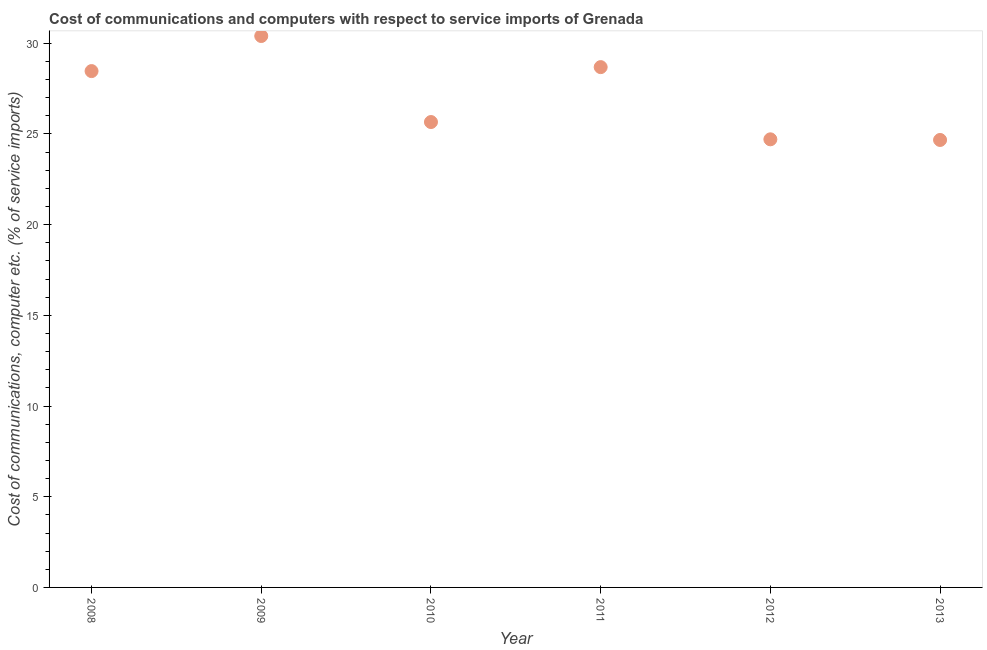What is the cost of communications and computer in 2011?
Your answer should be very brief. 28.68. Across all years, what is the maximum cost of communications and computer?
Ensure brevity in your answer.  30.4. Across all years, what is the minimum cost of communications and computer?
Give a very brief answer. 24.67. In which year was the cost of communications and computer maximum?
Your response must be concise. 2009. In which year was the cost of communications and computer minimum?
Give a very brief answer. 2013. What is the sum of the cost of communications and computer?
Your response must be concise. 162.57. What is the difference between the cost of communications and computer in 2009 and 2011?
Your response must be concise. 1.71. What is the average cost of communications and computer per year?
Give a very brief answer. 27.1. What is the median cost of communications and computer?
Provide a succinct answer. 27.06. Do a majority of the years between 2012 and 2008 (inclusive) have cost of communications and computer greater than 10 %?
Provide a short and direct response. Yes. What is the ratio of the cost of communications and computer in 2009 to that in 2011?
Your response must be concise. 1.06. Is the cost of communications and computer in 2008 less than that in 2012?
Provide a short and direct response. No. What is the difference between the highest and the second highest cost of communications and computer?
Your answer should be compact. 1.71. What is the difference between the highest and the lowest cost of communications and computer?
Your answer should be compact. 5.73. In how many years, is the cost of communications and computer greater than the average cost of communications and computer taken over all years?
Give a very brief answer. 3. Does the cost of communications and computer monotonically increase over the years?
Your response must be concise. No. How many dotlines are there?
Provide a short and direct response. 1. What is the title of the graph?
Provide a short and direct response. Cost of communications and computers with respect to service imports of Grenada. What is the label or title of the X-axis?
Ensure brevity in your answer.  Year. What is the label or title of the Y-axis?
Make the answer very short. Cost of communications, computer etc. (% of service imports). What is the Cost of communications, computer etc. (% of service imports) in 2008?
Give a very brief answer. 28.46. What is the Cost of communications, computer etc. (% of service imports) in 2009?
Offer a terse response. 30.4. What is the Cost of communications, computer etc. (% of service imports) in 2010?
Ensure brevity in your answer.  25.66. What is the Cost of communications, computer etc. (% of service imports) in 2011?
Ensure brevity in your answer.  28.68. What is the Cost of communications, computer etc. (% of service imports) in 2012?
Your answer should be compact. 24.7. What is the Cost of communications, computer etc. (% of service imports) in 2013?
Offer a terse response. 24.67. What is the difference between the Cost of communications, computer etc. (% of service imports) in 2008 and 2009?
Offer a terse response. -1.93. What is the difference between the Cost of communications, computer etc. (% of service imports) in 2008 and 2010?
Offer a very short reply. 2.81. What is the difference between the Cost of communications, computer etc. (% of service imports) in 2008 and 2011?
Ensure brevity in your answer.  -0.22. What is the difference between the Cost of communications, computer etc. (% of service imports) in 2008 and 2012?
Provide a succinct answer. 3.76. What is the difference between the Cost of communications, computer etc. (% of service imports) in 2008 and 2013?
Your response must be concise. 3.8. What is the difference between the Cost of communications, computer etc. (% of service imports) in 2009 and 2010?
Make the answer very short. 4.74. What is the difference between the Cost of communications, computer etc. (% of service imports) in 2009 and 2011?
Keep it short and to the point. 1.71. What is the difference between the Cost of communications, computer etc. (% of service imports) in 2009 and 2012?
Your answer should be compact. 5.69. What is the difference between the Cost of communications, computer etc. (% of service imports) in 2009 and 2013?
Offer a very short reply. 5.73. What is the difference between the Cost of communications, computer etc. (% of service imports) in 2010 and 2011?
Keep it short and to the point. -3.03. What is the difference between the Cost of communications, computer etc. (% of service imports) in 2010 and 2012?
Keep it short and to the point. 0.95. What is the difference between the Cost of communications, computer etc. (% of service imports) in 2010 and 2013?
Provide a succinct answer. 0.99. What is the difference between the Cost of communications, computer etc. (% of service imports) in 2011 and 2012?
Give a very brief answer. 3.98. What is the difference between the Cost of communications, computer etc. (% of service imports) in 2011 and 2013?
Give a very brief answer. 4.02. What is the difference between the Cost of communications, computer etc. (% of service imports) in 2012 and 2013?
Give a very brief answer. 0.04. What is the ratio of the Cost of communications, computer etc. (% of service imports) in 2008 to that in 2009?
Provide a short and direct response. 0.94. What is the ratio of the Cost of communications, computer etc. (% of service imports) in 2008 to that in 2010?
Provide a short and direct response. 1.11. What is the ratio of the Cost of communications, computer etc. (% of service imports) in 2008 to that in 2011?
Ensure brevity in your answer.  0.99. What is the ratio of the Cost of communications, computer etc. (% of service imports) in 2008 to that in 2012?
Keep it short and to the point. 1.15. What is the ratio of the Cost of communications, computer etc. (% of service imports) in 2008 to that in 2013?
Ensure brevity in your answer.  1.15. What is the ratio of the Cost of communications, computer etc. (% of service imports) in 2009 to that in 2010?
Your answer should be very brief. 1.19. What is the ratio of the Cost of communications, computer etc. (% of service imports) in 2009 to that in 2011?
Your response must be concise. 1.06. What is the ratio of the Cost of communications, computer etc. (% of service imports) in 2009 to that in 2012?
Your answer should be very brief. 1.23. What is the ratio of the Cost of communications, computer etc. (% of service imports) in 2009 to that in 2013?
Your answer should be very brief. 1.23. What is the ratio of the Cost of communications, computer etc. (% of service imports) in 2010 to that in 2011?
Your response must be concise. 0.89. What is the ratio of the Cost of communications, computer etc. (% of service imports) in 2010 to that in 2012?
Your answer should be very brief. 1.04. What is the ratio of the Cost of communications, computer etc. (% of service imports) in 2011 to that in 2012?
Provide a succinct answer. 1.16. What is the ratio of the Cost of communications, computer etc. (% of service imports) in 2011 to that in 2013?
Give a very brief answer. 1.16. 